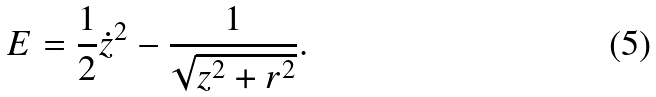Convert formula to latex. <formula><loc_0><loc_0><loc_500><loc_500>E = \frac { 1 } { 2 } \dot { z } ^ { 2 } - \frac { 1 } { \sqrt { z ^ { 2 } + r ^ { 2 } } } .</formula> 